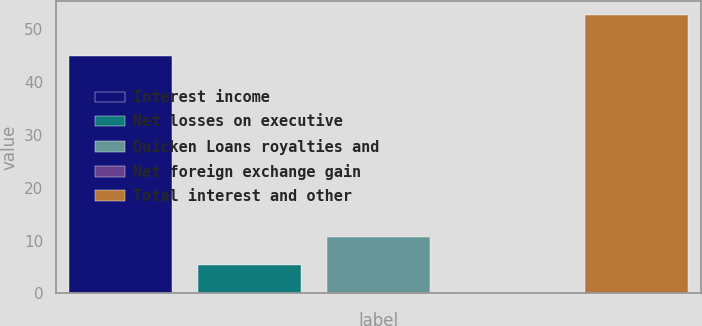Convert chart. <chart><loc_0><loc_0><loc_500><loc_500><bar_chart><fcel>Interest income<fcel>Net losses on executive<fcel>Quicken Loans royalties and<fcel>Net foreign exchange gain<fcel>Total interest and other<nl><fcel>45<fcel>5.36<fcel>10.62<fcel>0.1<fcel>52.7<nl></chart> 